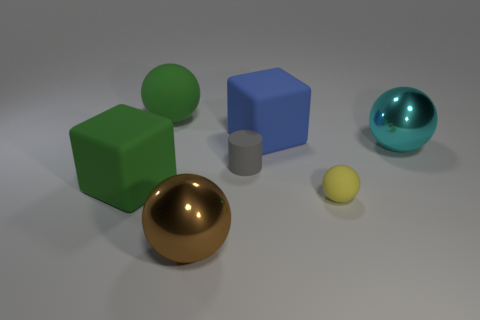Add 2 large purple blocks. How many objects exist? 9 Subtract all small rubber spheres. How many spheres are left? 3 Subtract all brown balls. How many balls are left? 3 Subtract all spheres. How many objects are left? 3 Add 7 tiny matte spheres. How many tiny matte spheres are left? 8 Add 5 green balls. How many green balls exist? 6 Subtract 0 blue cylinders. How many objects are left? 7 Subtract all brown balls. Subtract all purple cubes. How many balls are left? 3 Subtract all cylinders. Subtract all big cubes. How many objects are left? 4 